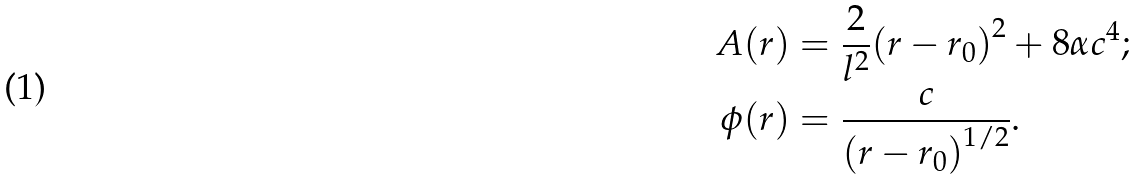Convert formula to latex. <formula><loc_0><loc_0><loc_500><loc_500>A ( r ) & = \frac { 2 } { l ^ { 2 } } { ( r - r _ { 0 } ) } ^ { 2 } + 8 \alpha c ^ { 4 } ; \\ \phi ( r ) & = \frac { c } { { ( r - r _ { 0 } ) } ^ { 1 / 2 } } .</formula> 